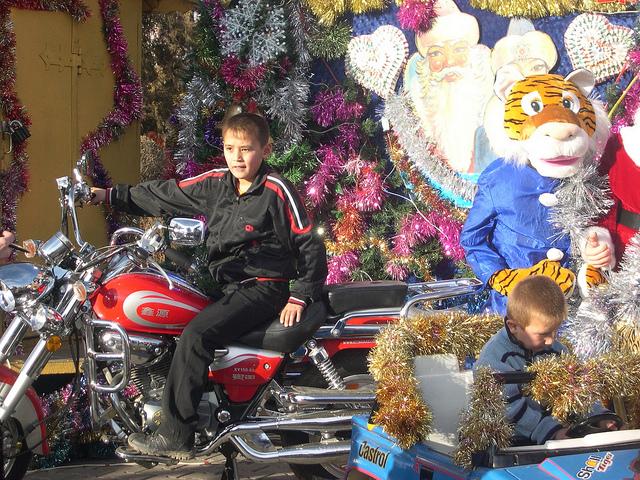What holiday is being celebrated?
Concise answer only. Christmas. Is the tiger real?
Short answer required. No. Where is the yellow horn?
Short answer required. Nowhere. What kind of motorcycle?
Write a very short answer. Honda. Are the toys valuable?
Be succinct. Yes. 